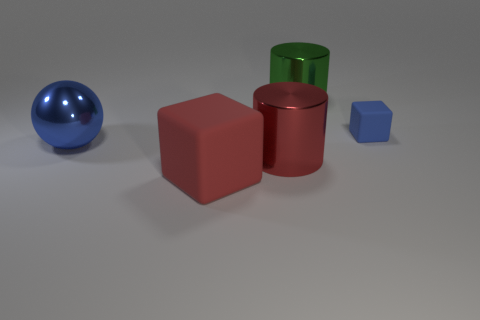There is a big shiny thing that is left of the large metal cylinder that is left of the green metal thing; what color is it?
Make the answer very short. Blue. What is the color of the other big object that is the same shape as the green object?
Provide a succinct answer. Red. How many cylinders have the same color as the tiny matte thing?
Give a very brief answer. 0. There is a tiny matte block; is its color the same as the cylinder behind the blue metal object?
Your answer should be compact. No. What shape is the thing that is behind the shiny sphere and on the left side of the small blue rubber block?
Ensure brevity in your answer.  Cylinder. What material is the blue object that is to the right of the large object on the right side of the large cylinder that is in front of the big green cylinder made of?
Provide a short and direct response. Rubber. Are there more cubes that are on the right side of the tiny blue object than tiny cubes that are behind the big green object?
Give a very brief answer. No. What number of large objects are the same material as the blue cube?
Your answer should be compact. 1. There is a rubber object in front of the tiny block; is it the same shape as the red thing right of the red rubber block?
Make the answer very short. No. What color is the big cylinder in front of the green cylinder?
Offer a very short reply. Red. 